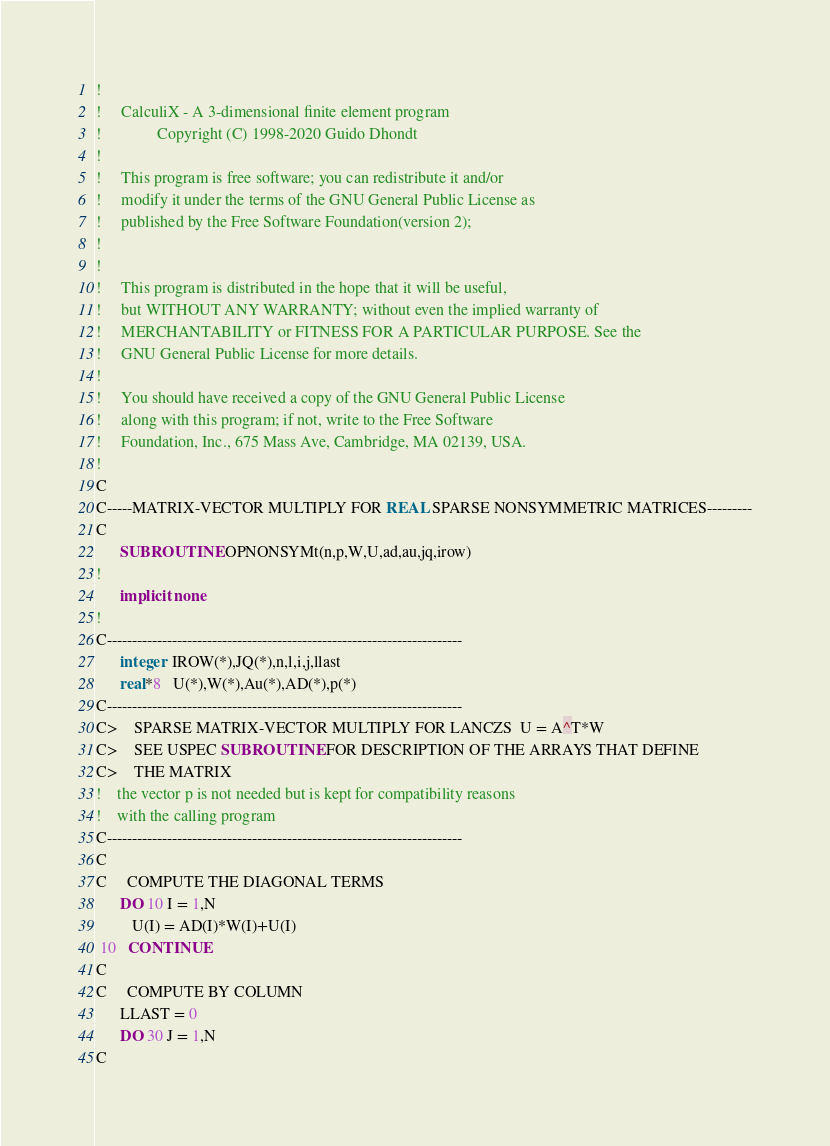Convert code to text. <code><loc_0><loc_0><loc_500><loc_500><_FORTRAN_>!
!     CalculiX - A 3-dimensional finite element program
!              Copyright (C) 1998-2020 Guido Dhondt
!
!     This program is free software; you can redistribute it and/or
!     modify it under the terms of the GNU General Public License as
!     published by the Free Software Foundation(version 2);
!     
!
!     This program is distributed in the hope that it will be useful,
!     but WITHOUT ANY WARRANTY; without even the implied warranty of 
!     MERCHANTABILITY or FITNESS FOR A PARTICULAR PURPOSE. See the 
!     GNU General Public License for more details.
!
!     You should have received a copy of the GNU General Public License
!     along with this program; if not, write to the Free Software
!     Foundation, Inc., 675 Mass Ave, Cambridge, MA 02139, USA.
!
C
C-----MATRIX-VECTOR MULTIPLY FOR REAL SPARSE NONSYMMETRIC MATRICES---------
C
      SUBROUTINE OPNONSYMt(n,p,W,U,ad,au,jq,irow)
!
      implicit none
!
C-----------------------------------------------------------------------
      integer  IROW(*),JQ(*),n,l,i,j,llast
      real*8   U(*),W(*),Au(*),AD(*),p(*)
C-----------------------------------------------------------------------
C>    SPARSE MATRIX-VECTOR MULTIPLY FOR LANCZS  U = A^T*W
C>    SEE USPEC SUBROUTINE FOR DESCRIPTION OF THE ARRAYS THAT DEFINE
C>    THE MATRIX
!    the vector p is not needed but is kept for compatibility reasons
!    with the calling program
C-----------------------------------------------------------------------
C
C     COMPUTE THE DIAGONAL TERMS
      DO 10 I = 1,N
         U(I) = AD(I)*W(I)+U(I)
 10   CONTINUE
C
C     COMPUTE BY COLUMN
      LLAST = 0
      DO 30 J = 1,N
C</code> 